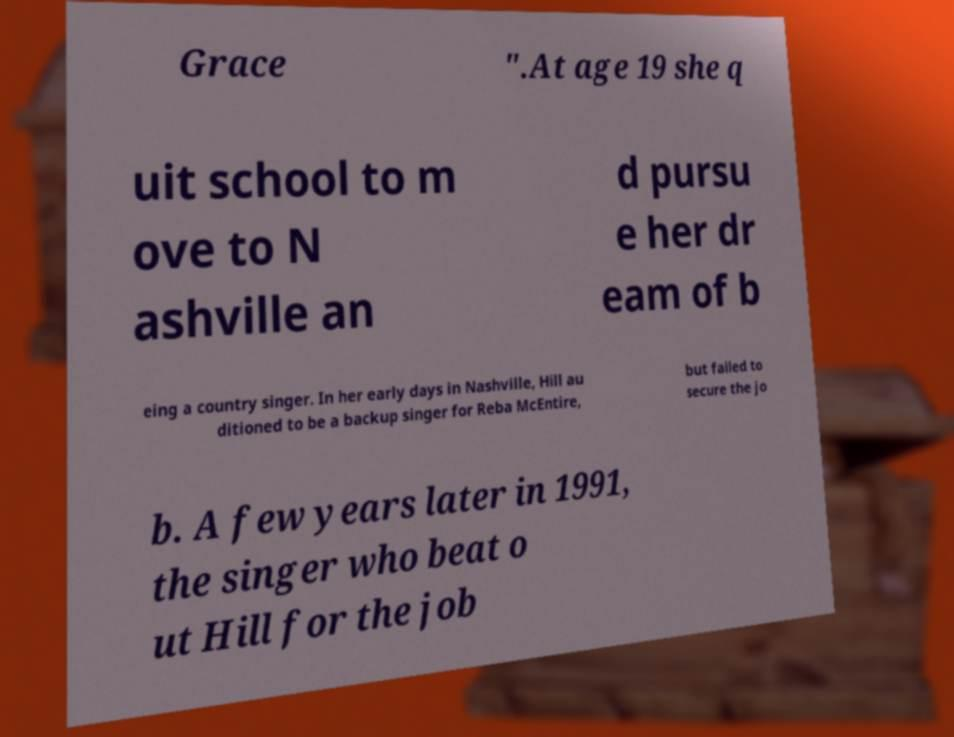For documentation purposes, I need the text within this image transcribed. Could you provide that? Grace ".At age 19 she q uit school to m ove to N ashville an d pursu e her dr eam of b eing a country singer. In her early days in Nashville, Hill au ditioned to be a backup singer for Reba McEntire, but failed to secure the jo b. A few years later in 1991, the singer who beat o ut Hill for the job 